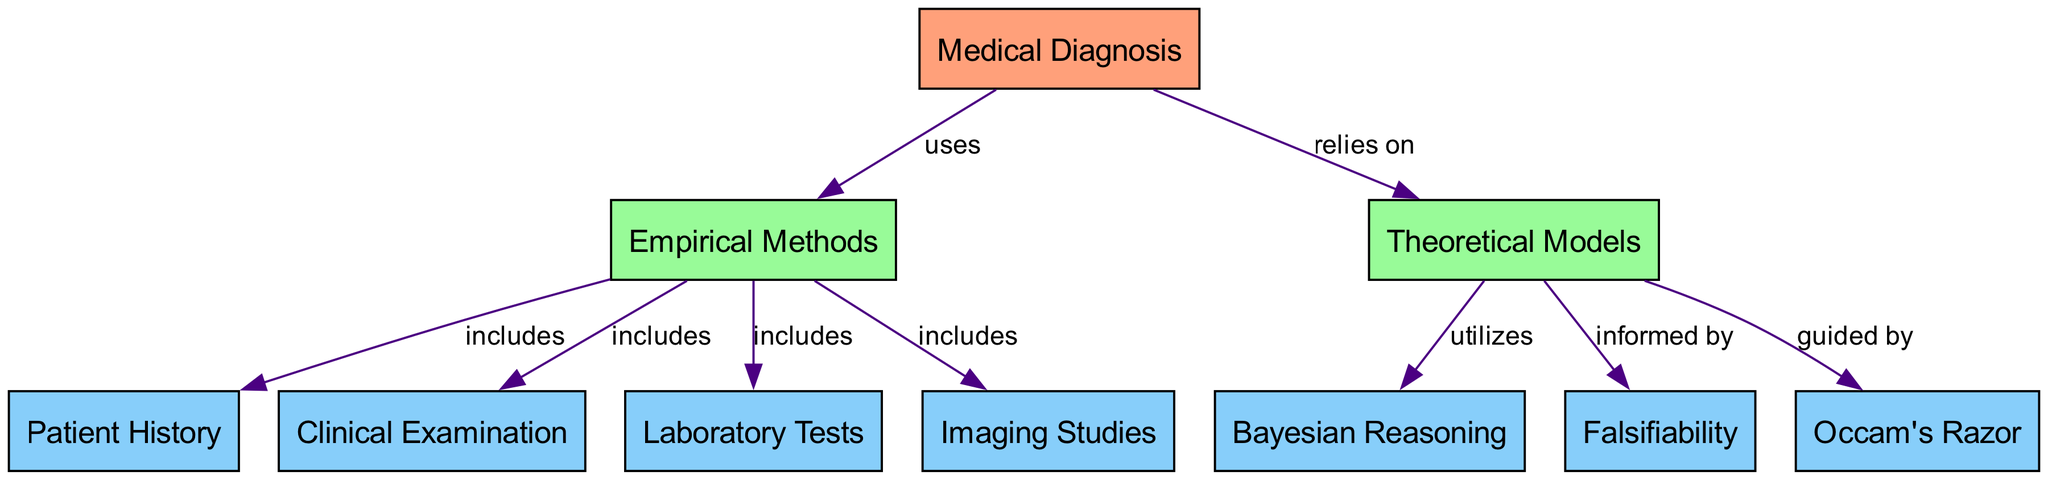What is the central concept of the diagram? The central concept, represented by the node labeled "Medical Diagnosis," is the main theme around which other concepts are structured and interrelated.
Answer: Medical Diagnosis How many nodes are there in the diagram? The diagram contains a total of 10 nodes, each representing different elements related to medical diagnosis and epistemology.
Answer: 10 Which method is indicated as utilizing Bayesian Reasoning? The node labeled "Theoretical Models" indicates that it utilizes Bayesian Reasoning, which is a framework for updating beliefs based on evidence.
Answer: Theoretical Models What type of relationship exists between "Empirical Methods" and "Patient History"? The relationship is a "includes" type, meaning that "Patient History" is one of the components included in the broader category of "Empirical Methods."
Answer: includes Which epistemological theory is guided by Occam's Razor? The node "Theoretical Models" is guided by Occam's Razor, which suggests that the simplest explanation is often the best.
Answer: Theoretical Models How does "Clinical Examination" relate to "Empirical Methods"? "Clinical Examination" is included in "Empirical Methods," indicating it is a fundamental part of diagnosing using observable evidence.
Answer: includes Which node is informed by Falsifiability? The node "Theoretical Models" is informed by Falsifiability, suggesting that theories must be testable and refutable to be scientifically valid.
Answer: Theoretical Models What is the primary connection between "Medical Diagnosis" and "Theoretical Models"? The primary connection is that "Medical Diagnosis" relies on "Theoretical Models," highlighting the importance of theoretical underpinnings in diagnosis.
Answer: relies on Which diagnostic technique does not fall under Empirical Methods? "Theoretical Models" does not fall under Empirical Methods as it is a distinct approach focusing on theoretical frameworks rather than direct observation.
Answer: Theoretical Models 